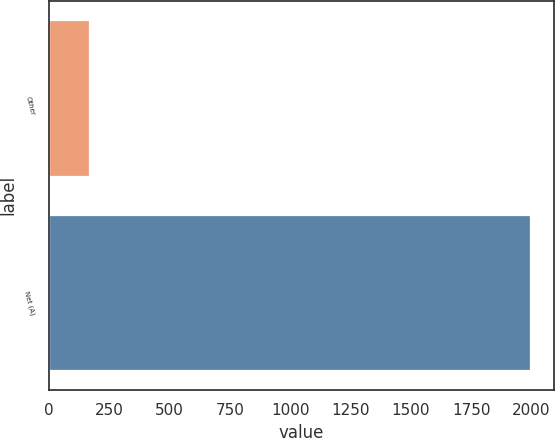Convert chart. <chart><loc_0><loc_0><loc_500><loc_500><bar_chart><fcel>Other<fcel>Net (A)<nl><fcel>164<fcel>1992<nl></chart> 